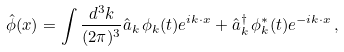<formula> <loc_0><loc_0><loc_500><loc_500>\hat { \phi } ( x ) = \int \frac { d ^ { 3 } k } { ( 2 \pi ) ^ { 3 } } \hat { a } _ { k } \, \phi _ { k } ( t ) e ^ { i k \cdot x } + \hat { a } _ { k } ^ { \dag } \, \phi _ { k } ^ { \ast } ( t ) e ^ { - i k \cdot x } \, ,</formula> 